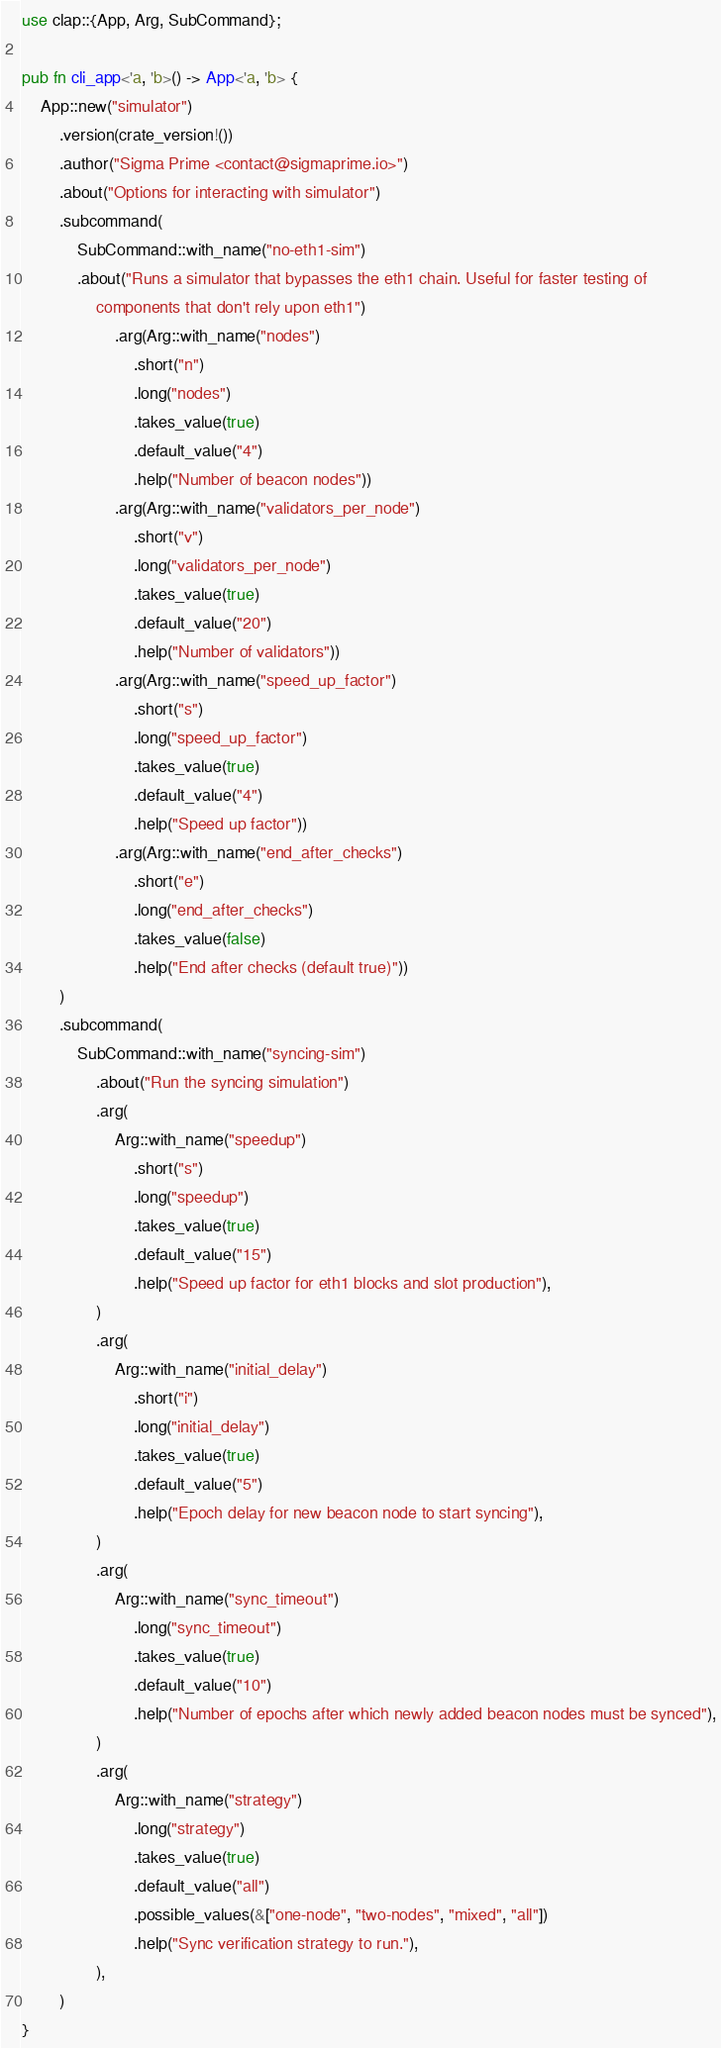Convert code to text. <code><loc_0><loc_0><loc_500><loc_500><_Rust_>use clap::{App, Arg, SubCommand};

pub fn cli_app<'a, 'b>() -> App<'a, 'b> {
    App::new("simulator")
        .version(crate_version!())
        .author("Sigma Prime <contact@sigmaprime.io>")
        .about("Options for interacting with simulator")
        .subcommand(
            SubCommand::with_name("no-eth1-sim")
            .about("Runs a simulator that bypasses the eth1 chain. Useful for faster testing of
                components that don't rely upon eth1")
                    .arg(Arg::with_name("nodes")
                        .short("n")
                        .long("nodes")
                        .takes_value(true)
                        .default_value("4")
                        .help("Number of beacon nodes"))
                    .arg(Arg::with_name("validators_per_node")
                        .short("v")
                        .long("validators_per_node")
                        .takes_value(true)
                        .default_value("20")
                        .help("Number of validators"))
                    .arg(Arg::with_name("speed_up_factor")
                        .short("s")
                        .long("speed_up_factor")
                        .takes_value(true)
                        .default_value("4")
                        .help("Speed up factor"))
                    .arg(Arg::with_name("end_after_checks")
                        .short("e")
                        .long("end_after_checks")
                        .takes_value(false)
                        .help("End after checks (default true)"))
        )
        .subcommand(
            SubCommand::with_name("syncing-sim")
                .about("Run the syncing simulation")
                .arg(
                    Arg::with_name("speedup")
                        .short("s")
                        .long("speedup")
                        .takes_value(true)
                        .default_value("15")
                        .help("Speed up factor for eth1 blocks and slot production"),
                )
                .arg(
                    Arg::with_name("initial_delay")
                        .short("i")
                        .long("initial_delay")
                        .takes_value(true)
                        .default_value("5")
                        .help("Epoch delay for new beacon node to start syncing"),
                )
                .arg(
                    Arg::with_name("sync_timeout")
                        .long("sync_timeout")
                        .takes_value(true)
                        .default_value("10")
                        .help("Number of epochs after which newly added beacon nodes must be synced"),
                )
                .arg(
                    Arg::with_name("strategy")
                        .long("strategy")
                        .takes_value(true)
                        .default_value("all")
                        .possible_values(&["one-node", "two-nodes", "mixed", "all"])
                        .help("Sync verification strategy to run."),
                ),
        )
}
</code> 